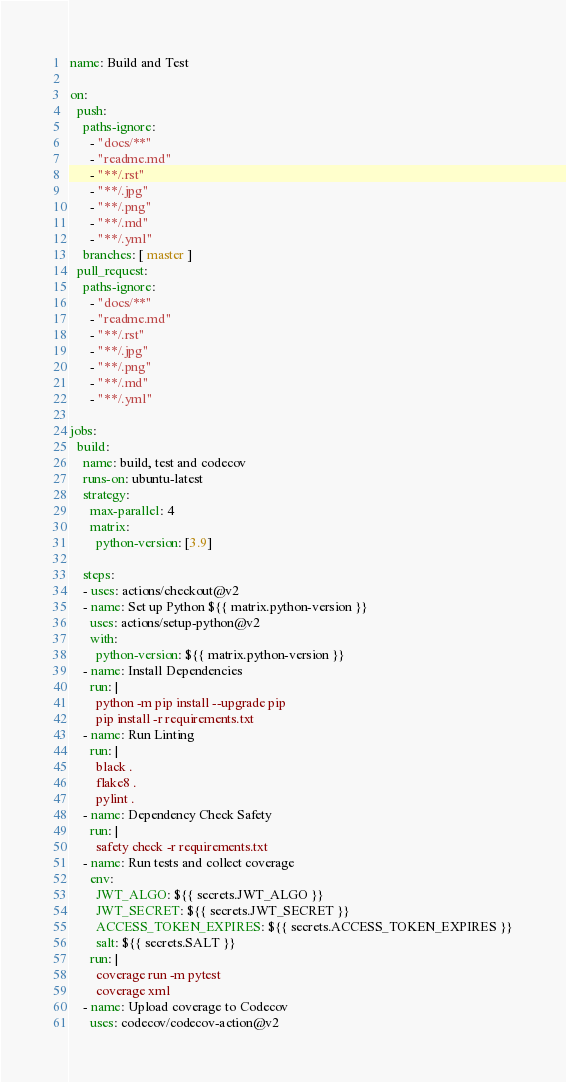<code> <loc_0><loc_0><loc_500><loc_500><_YAML_>name: Build and Test

on:
  push:
    paths-ignore:
      - "docs/**"
      - "readme.md"
      - "**/.rst"
      - "**/.jpg"
      - "**/.png"
      - "**/.md"
      - "**/.yml"
    branches: [ master ]
  pull_request:
    paths-ignore:
      - "docs/**"
      - "readme.md"
      - "**/.rst"
      - "**/.jpg"
      - "**/.png"
      - "**/.md"
      - "**/.yml"

jobs:
  build:
    name: build, test and codecov
    runs-on: ubuntu-latest
    strategy:
      max-parallel: 4
      matrix:
        python-version: [3.9]

    steps:
    - uses: actions/checkout@v2
    - name: Set up Python ${{ matrix.python-version }}
      uses: actions/setup-python@v2
      with:
        python-version: ${{ matrix.python-version }}
    - name: Install Dependencies
      run: |
        python -m pip install --upgrade pip
        pip install -r requirements.txt
    - name: Run Linting
      run: |
        black .
        flake8 .
        pylint .
    - name: Dependency Check Safety
      run: |
        safety check -r requirements.txt
    - name: Run tests and collect coverage
      env:
        JWT_ALGO: ${{ secrets.JWT_ALGO }}
        JWT_SECRET: ${{ secrets.JWT_SECRET }}
        ACCESS_TOKEN_EXPIRES: ${{ secrets.ACCESS_TOKEN_EXPIRES }}
        salt: ${{ secrets.SALT }}
      run: |
        coverage run -m pytest
        coverage xml
    - name: Upload coverage to Codecov
      uses: codecov/codecov-action@v2


</code> 